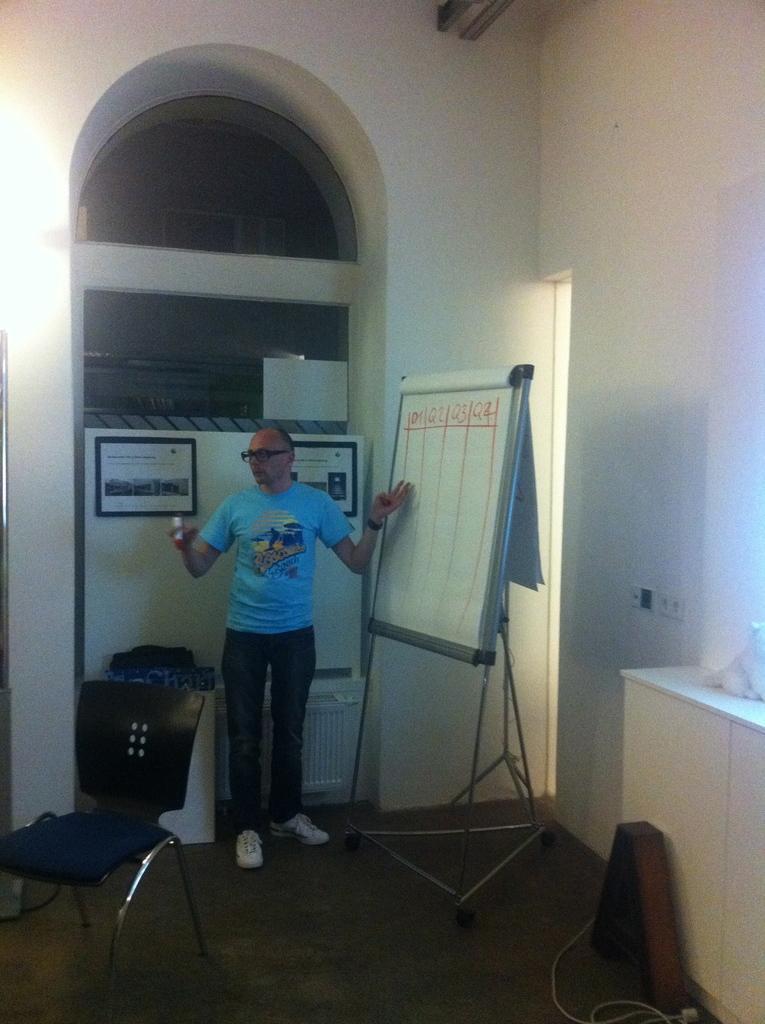How would you summarize this image in a sentence or two? In this image I can see the person standing and holding some object and the person is wearing blue and black color dress and I can also see the board and something is attached to the wall and the wall is in white color. 